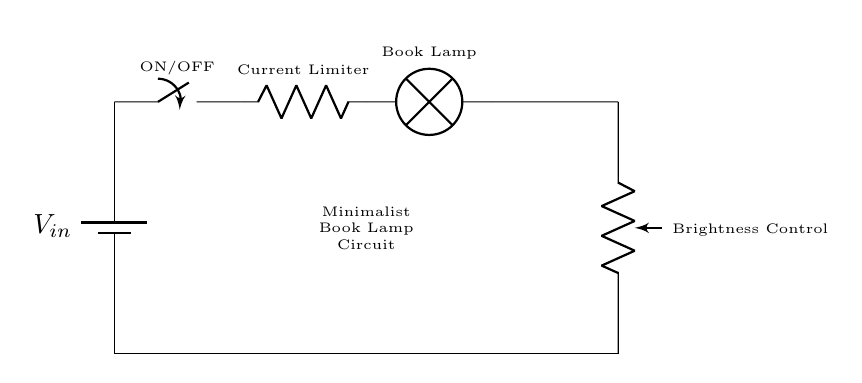What is the purpose of the lamp in the circuit? The lamp serves as the main light source for the book lamp circuit, providing illumination for late-night writing sessions.
Answer: illumination What component is used to control brightness? A potentiometer is used in this circuit to vary the resistance, allowing for adjustment of the brightness of the lamp.
Answer: potentiometer How many power sources are in the circuit? There is one battery in the circuit, which serves as the sole power source for the lamp and other components.
Answer: one What does the switch do in the circuit? The switch acts as an ON/OFF control for the entire circuit, allowing the user to easily turn the lamp on or off.
Answer: ON/OFF What type of circuit is this? This is a simple series circuit where all components are connected in a single loop, allowing for current to flow through each component sequentially.
Answer: series How does the current limiter function in this circuit? The current limiter regulates the amount of current flowing to the lamp, preventing it from exceeding safe levels and thus avoiding damage.
Answer: regulate What is the minimum voltage required for the lamp to operate? The minimum voltage is not specified in the circuit, but typically it would be determined by the specifications of the lamp used.
Answer: unspecified 